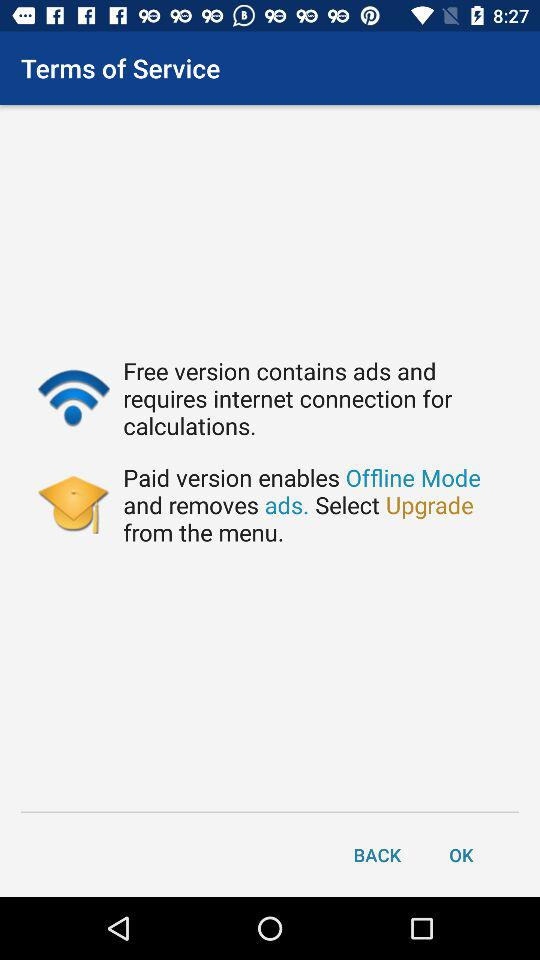Which version requires an internet connection for calculations?
Answer the question using a single word or phrase. Free 